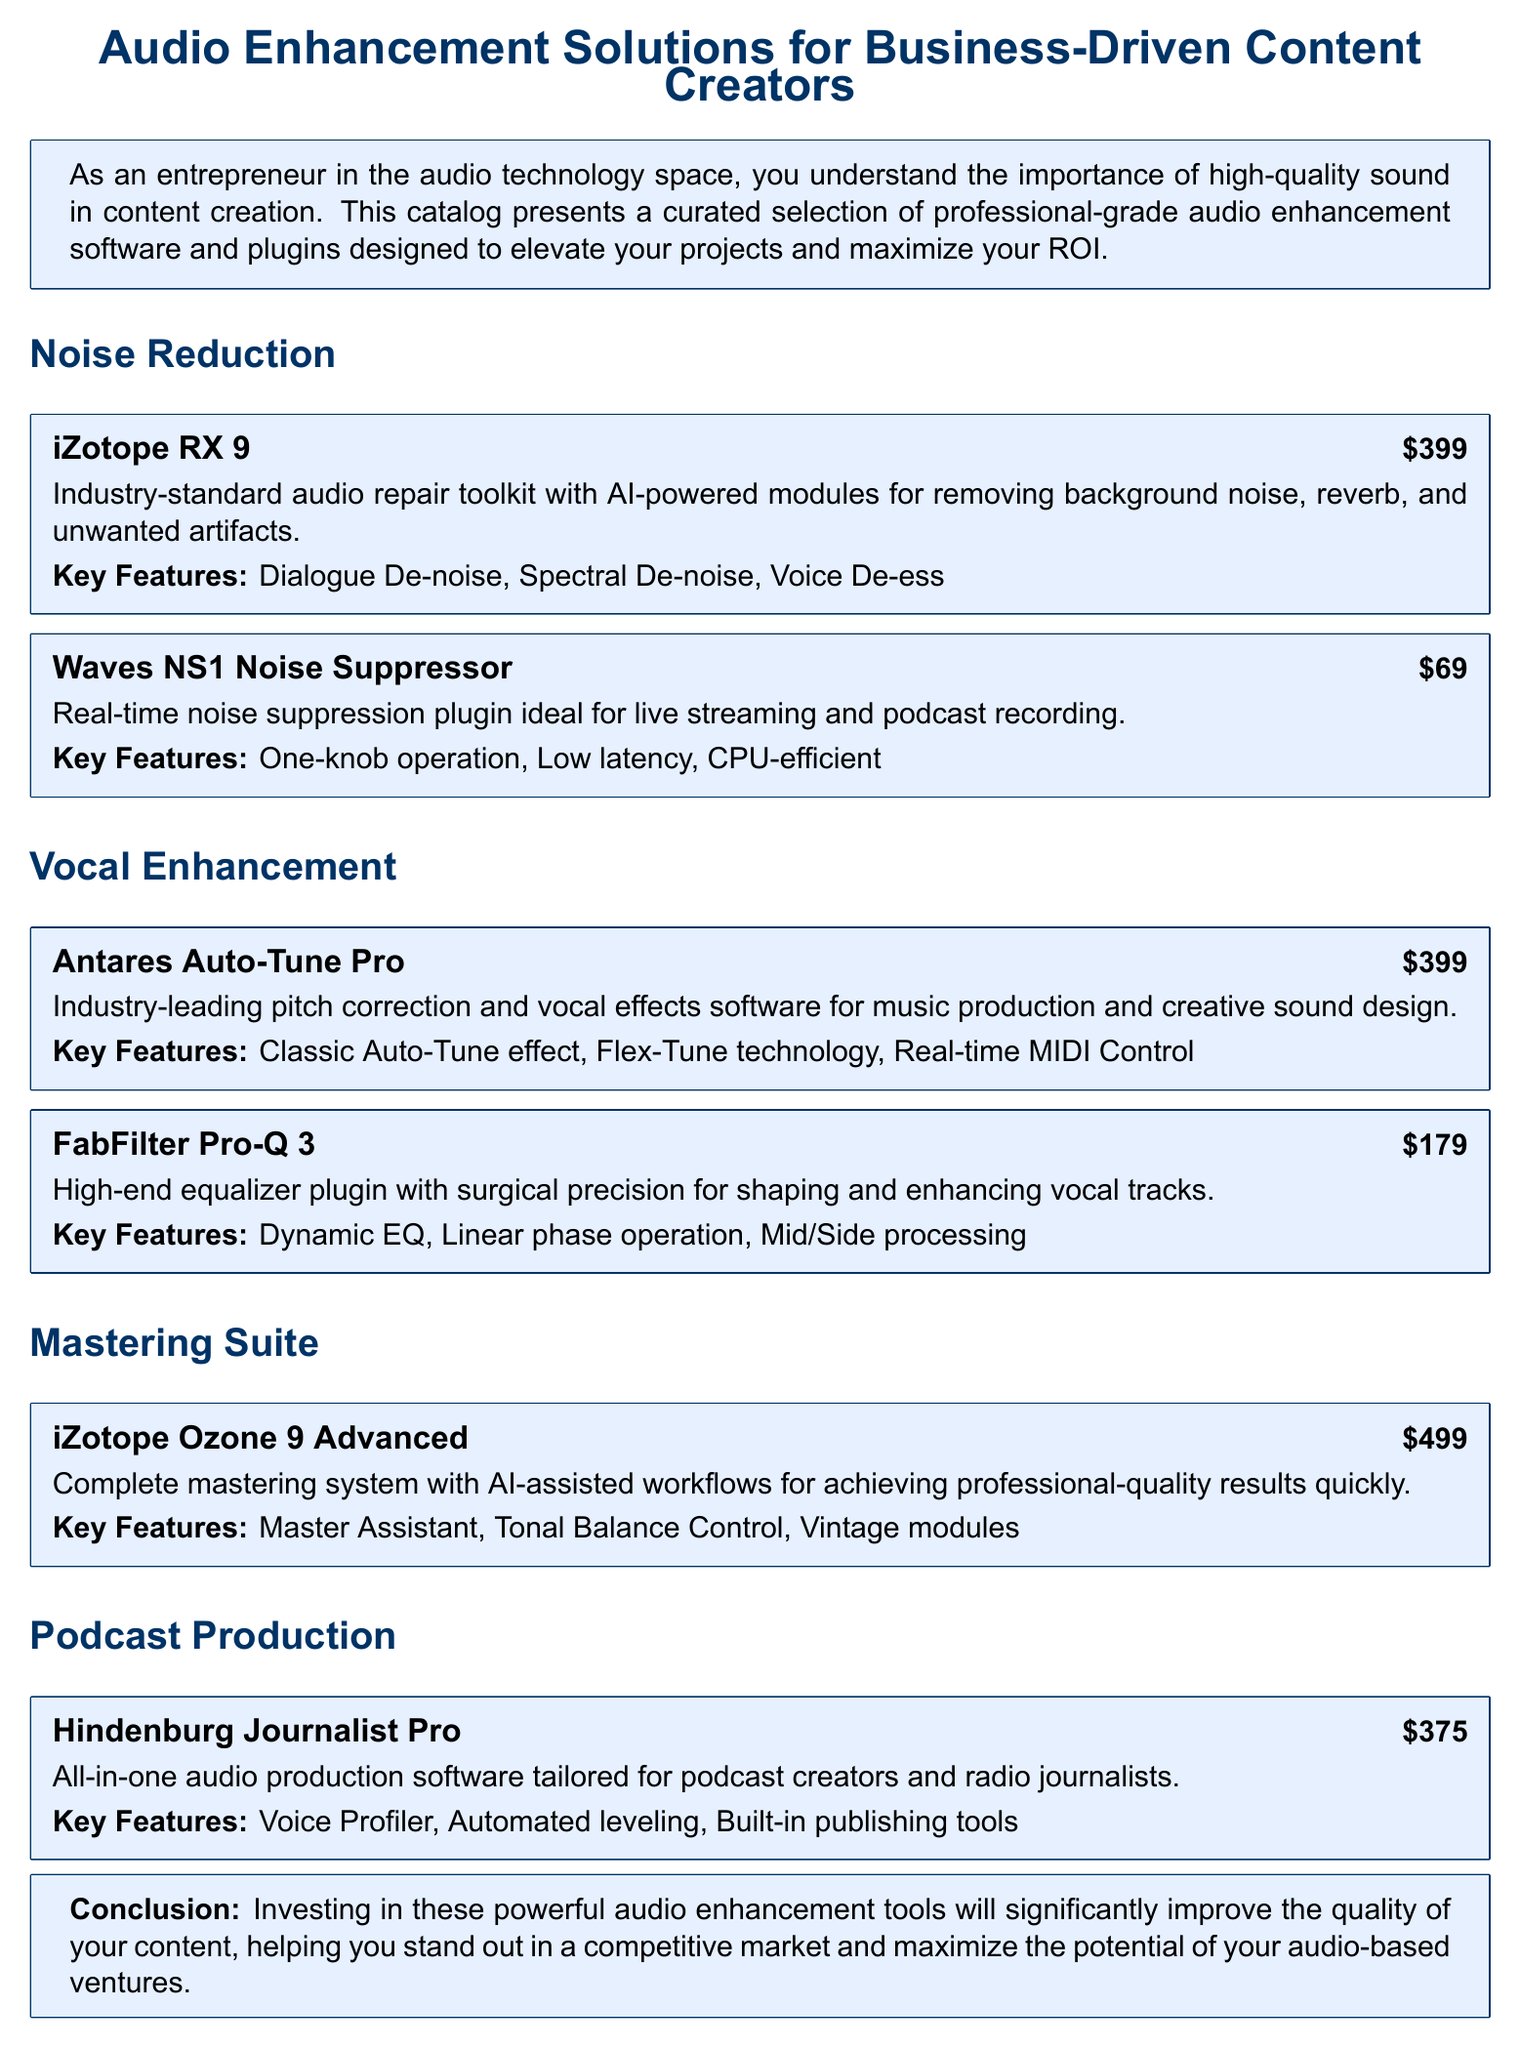What is the price of iZotope RX 9? The price of iZotope RX 9 is listed as $399.
Answer: $399 What functionality does Waves NS1 Noise Suppressor provide? Waves NS1 Noise Suppressor is a real-time noise suppression plugin ideal for live streaming and podcast recording.
Answer: Real-time noise suppression What is a key feature of Antares Auto-Tune Pro? One key feature of Antares Auto-Tune Pro is the Classic Auto-Tune effect.
Answer: Classic Auto-Tune effect Which software is tailored specifically for podcast creators? Hindenburg Journalist Pro is the all-in-one audio production software tailored for podcast creators.
Answer: Hindenburg Journalist Pro What is the total price of the plugins mentioned in the Vocal Enhancement section? The total price is calculated as $399 (Antares Auto-Tune Pro) + $179 (FabFilter Pro-Q 3) = $578.
Answer: $578 What does iZotope Ozone 9 Advanced feature for mastering? iZotope Ozone 9 Advanced features the Master Assistant for achieving professional-quality results quickly.
Answer: Master Assistant How many products are listed under Noise Reduction? There are two products listed under Noise Reduction.
Answer: Two What type of document is this? This document is a catalog of audio enhancement software and plugins.
Answer: Catalog 